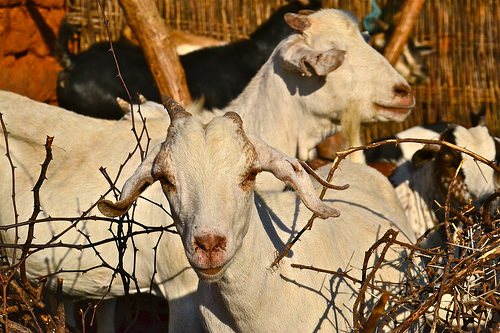<image>
Is the goat next to the tree? Yes. The goat is positioned adjacent to the tree, located nearby in the same general area. 